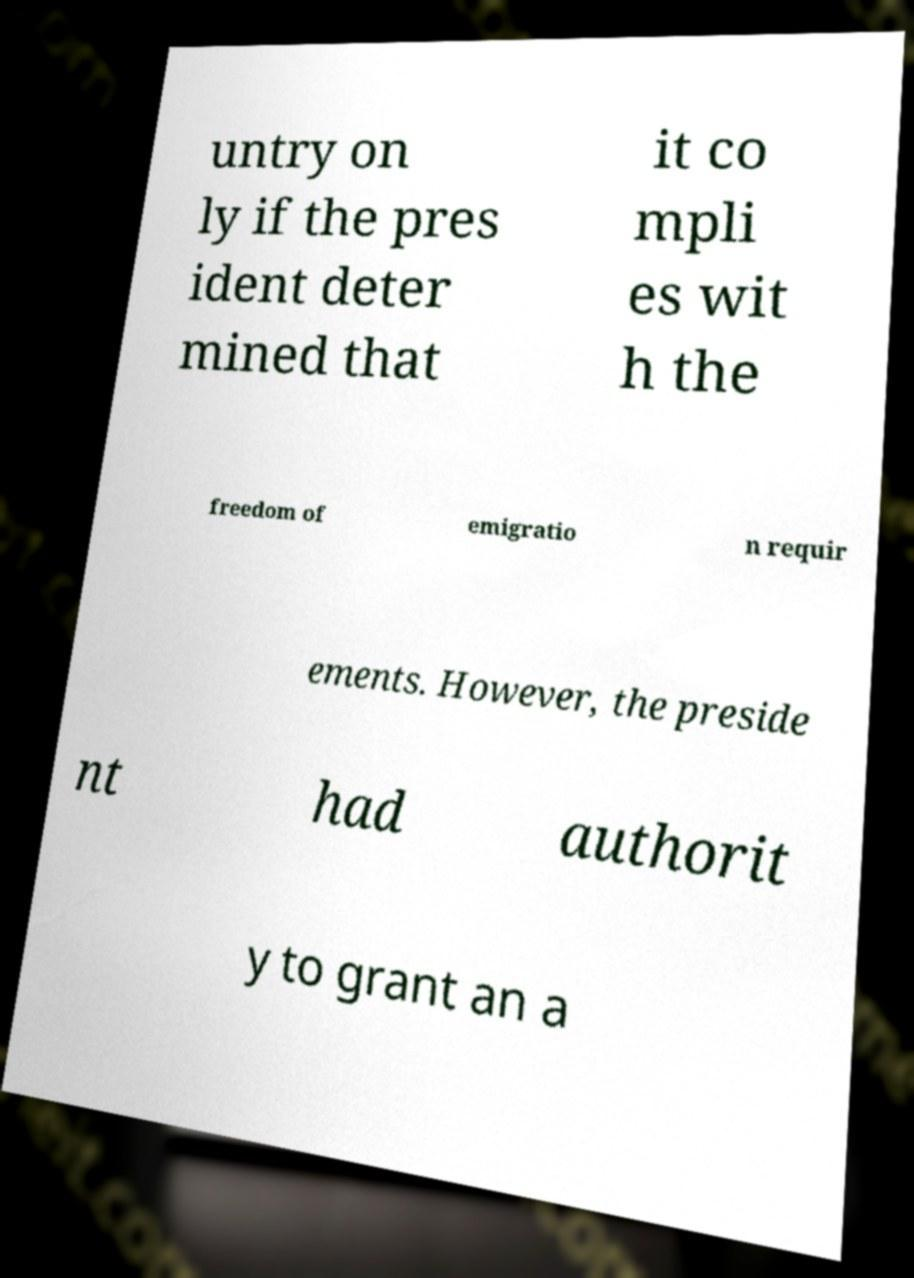Please read and relay the text visible in this image. What does it say? untry on ly if the pres ident deter mined that it co mpli es wit h the freedom of emigratio n requir ements. However, the preside nt had authorit y to grant an a 